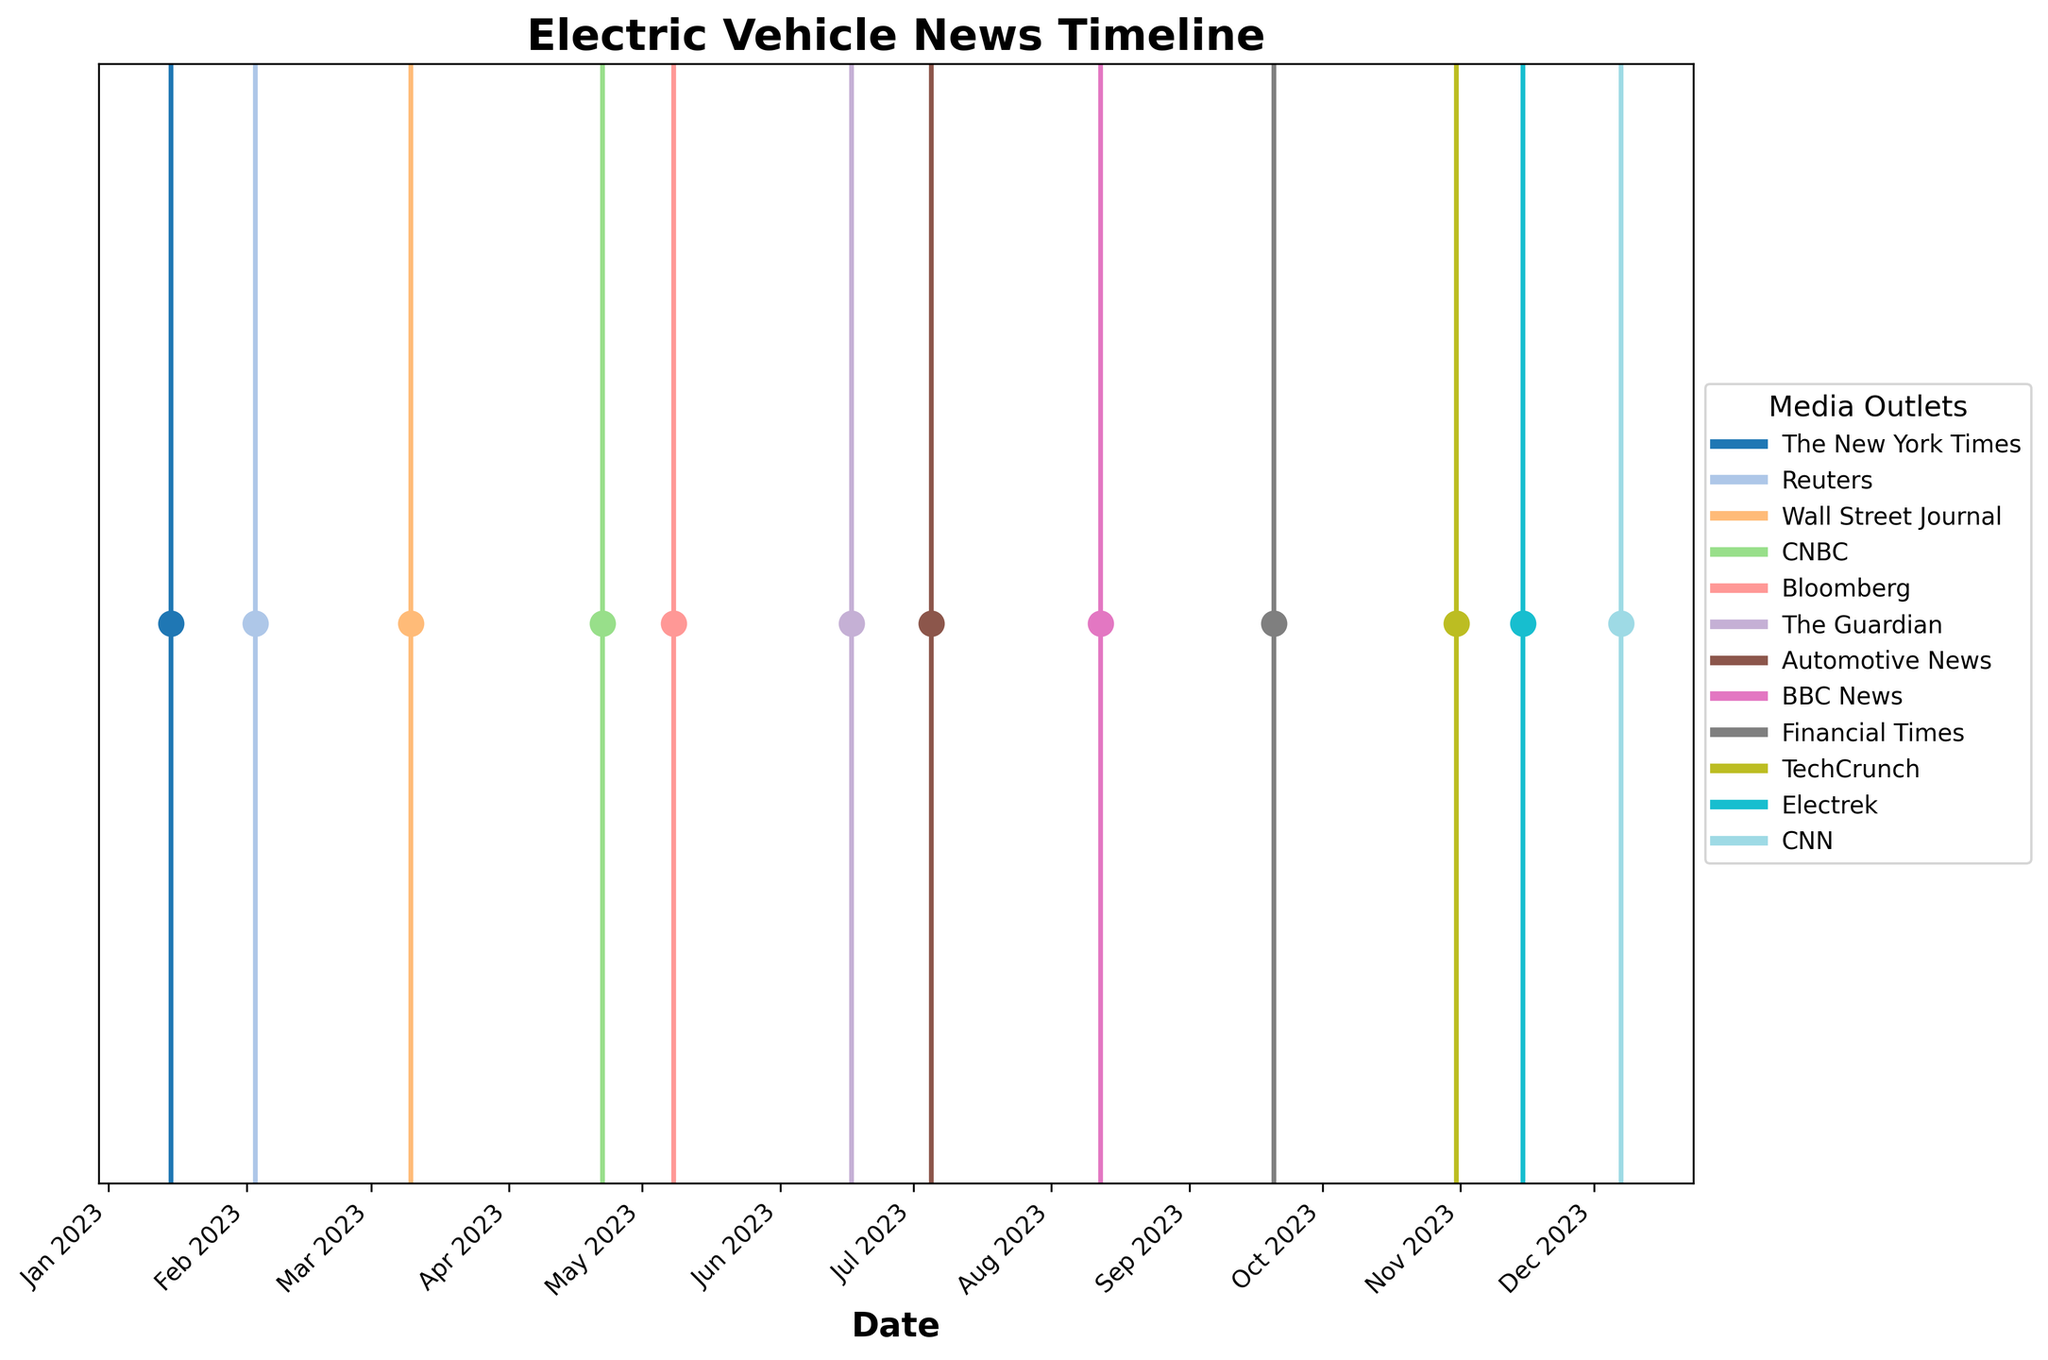Which media outlet reported the Tesla announcement in January? Look for the event in January on the timeline, find the label for the Tesla announcement, and see which media outlet is associated with it.
Answer: The New York Times What is the title of the figure? Read the title at the top of the figure, which summarizes its content.
Answer: Electric Vehicle News Timeline How many news articles were reported by Reuters? Identify the color associated with Reuters in the legend, then count the number of vertical lines in that color on the timeline.
Answer: 1 Which month had the highest number of news articles related to electric vehicles? Examine each month on the x-axis and count the number of event markers (vertical lines), then identify the month with the most markers.
Answer: May (or any month with the highest count based on visual examination) Which event occurred between the CNN report in December and the Electrek report in November? Find the CNN report in December and the Electrek report in November, then identify the event marker located between these two points on the timeline.
Answer: Rivian expands charging network across national parks Which two media outlets reported events in the same month? Look at the timeline and identify pairs of vertical lines that fall within the same month, then check the associated labels for media outlets.
Answer: Automotive News and BBC News reported in August What is the first event reported in the timeline? Locate the earliest date on the x-axis and read the event label associated with it.
Answer: Tesla announces new affordable EV model Which media outlet reported about Volkswagen's new battery gigafactory? Find the event related to Volkswagen's new battery gigafactory on the timeline and see which media outlet is mentioned.
Answer: Automotive News Compare the number of events reported by The Guardian and Financial Times. Which has more? Count the number of vertical lines associated with The Guardian and Financial Times, then compare the two counts.
Answer: The Guardian and Financial Times both reported one event each How many events were reported in the second half of the year (July to December)? Count the number of event markers (vertical lines) from July to December on the x-axis.
Answer: 6 